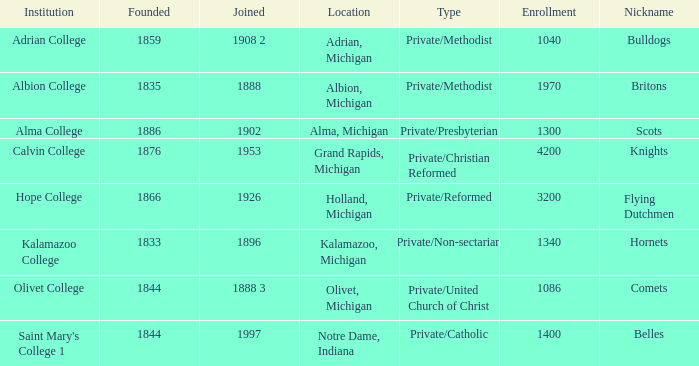Under belles, which is the most possible created? 1844.0. 